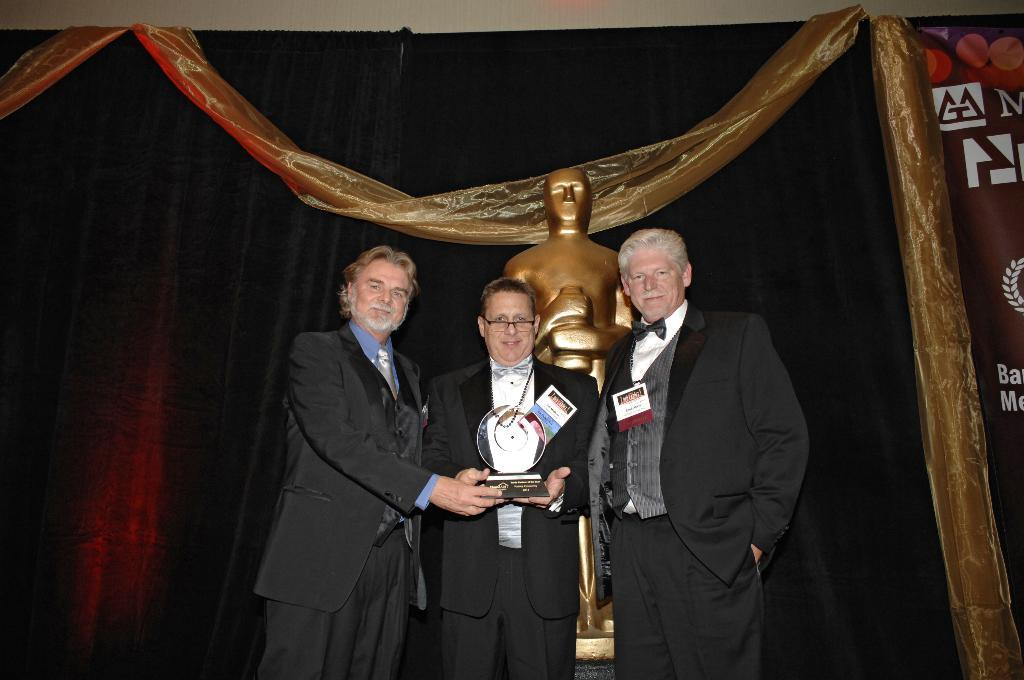How many people are in the image? There are three people standing in the image. What are the people wearing? The people are wearing suits. What are the people holding in the image? The people are holding a glass trophy. What can be seen behind the people? There is a sculpture behind the people. What type of background can be seen in the image? There are black curtains in the image. What is present at the back of the scene? There is a banner at the back of the scene. What type of religion is being practiced by the people in the image? There is no indication of any religious practice in the image; the people are simply holding a glass trophy. Are there any pets visible in the image? There are no pets present in the image. 